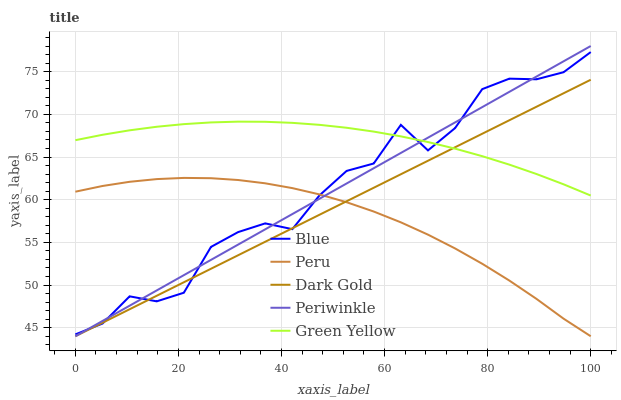Does Peru have the minimum area under the curve?
Answer yes or no. Yes. Does Green Yellow have the maximum area under the curve?
Answer yes or no. Yes. Does Periwinkle have the minimum area under the curve?
Answer yes or no. No. Does Periwinkle have the maximum area under the curve?
Answer yes or no. No. Is Periwinkle the smoothest?
Answer yes or no. Yes. Is Blue the roughest?
Answer yes or no. Yes. Is Green Yellow the smoothest?
Answer yes or no. No. Is Green Yellow the roughest?
Answer yes or no. No. Does Periwinkle have the lowest value?
Answer yes or no. Yes. Does Green Yellow have the lowest value?
Answer yes or no. No. Does Periwinkle have the highest value?
Answer yes or no. Yes. Does Green Yellow have the highest value?
Answer yes or no. No. Is Peru less than Green Yellow?
Answer yes or no. Yes. Is Green Yellow greater than Peru?
Answer yes or no. Yes. Does Peru intersect Dark Gold?
Answer yes or no. Yes. Is Peru less than Dark Gold?
Answer yes or no. No. Is Peru greater than Dark Gold?
Answer yes or no. No. Does Peru intersect Green Yellow?
Answer yes or no. No. 